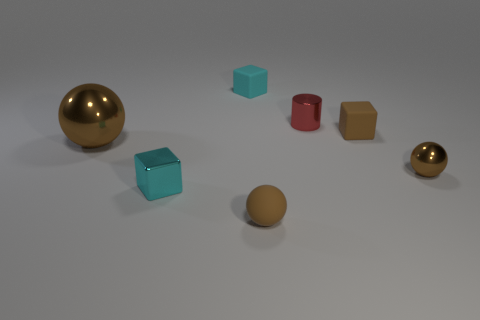Subtract all tiny brown blocks. How many blocks are left? 2 Subtract all cyan cylinders. How many cyan cubes are left? 2 Add 2 tiny cyan shiny cubes. How many objects exist? 9 Subtract all brown cubes. How many cubes are left? 2 Subtract all blue cubes. Subtract all cyan spheres. How many cubes are left? 3 Subtract all shiny cylinders. Subtract all large brown shiny balls. How many objects are left? 5 Add 4 small matte balls. How many small matte balls are left? 5 Add 6 small blocks. How many small blocks exist? 9 Subtract 0 brown cylinders. How many objects are left? 7 Subtract all balls. How many objects are left? 4 